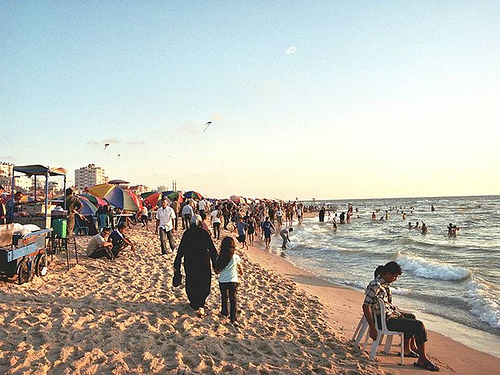Is the woman to the left or to the right of the people on the left side? The woman is walking on the right side of the image, past the multiple groups of people gathered around near the water. 